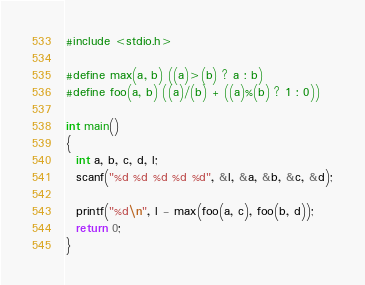<code> <loc_0><loc_0><loc_500><loc_500><_C_>#include <stdio.h>

#define max(a, b) ((a)>(b) ? a : b)
#define foo(a, b) ((a)/(b) + ((a)%(b) ? 1 : 0))

int main()
{
  int a, b, c, d, l;
  scanf("%d %d %d %d %d", &l, &a, &b, &c, &d);

  printf("%d\n", l - max(foo(a, c), foo(b, d));
  return 0;
}</code> 